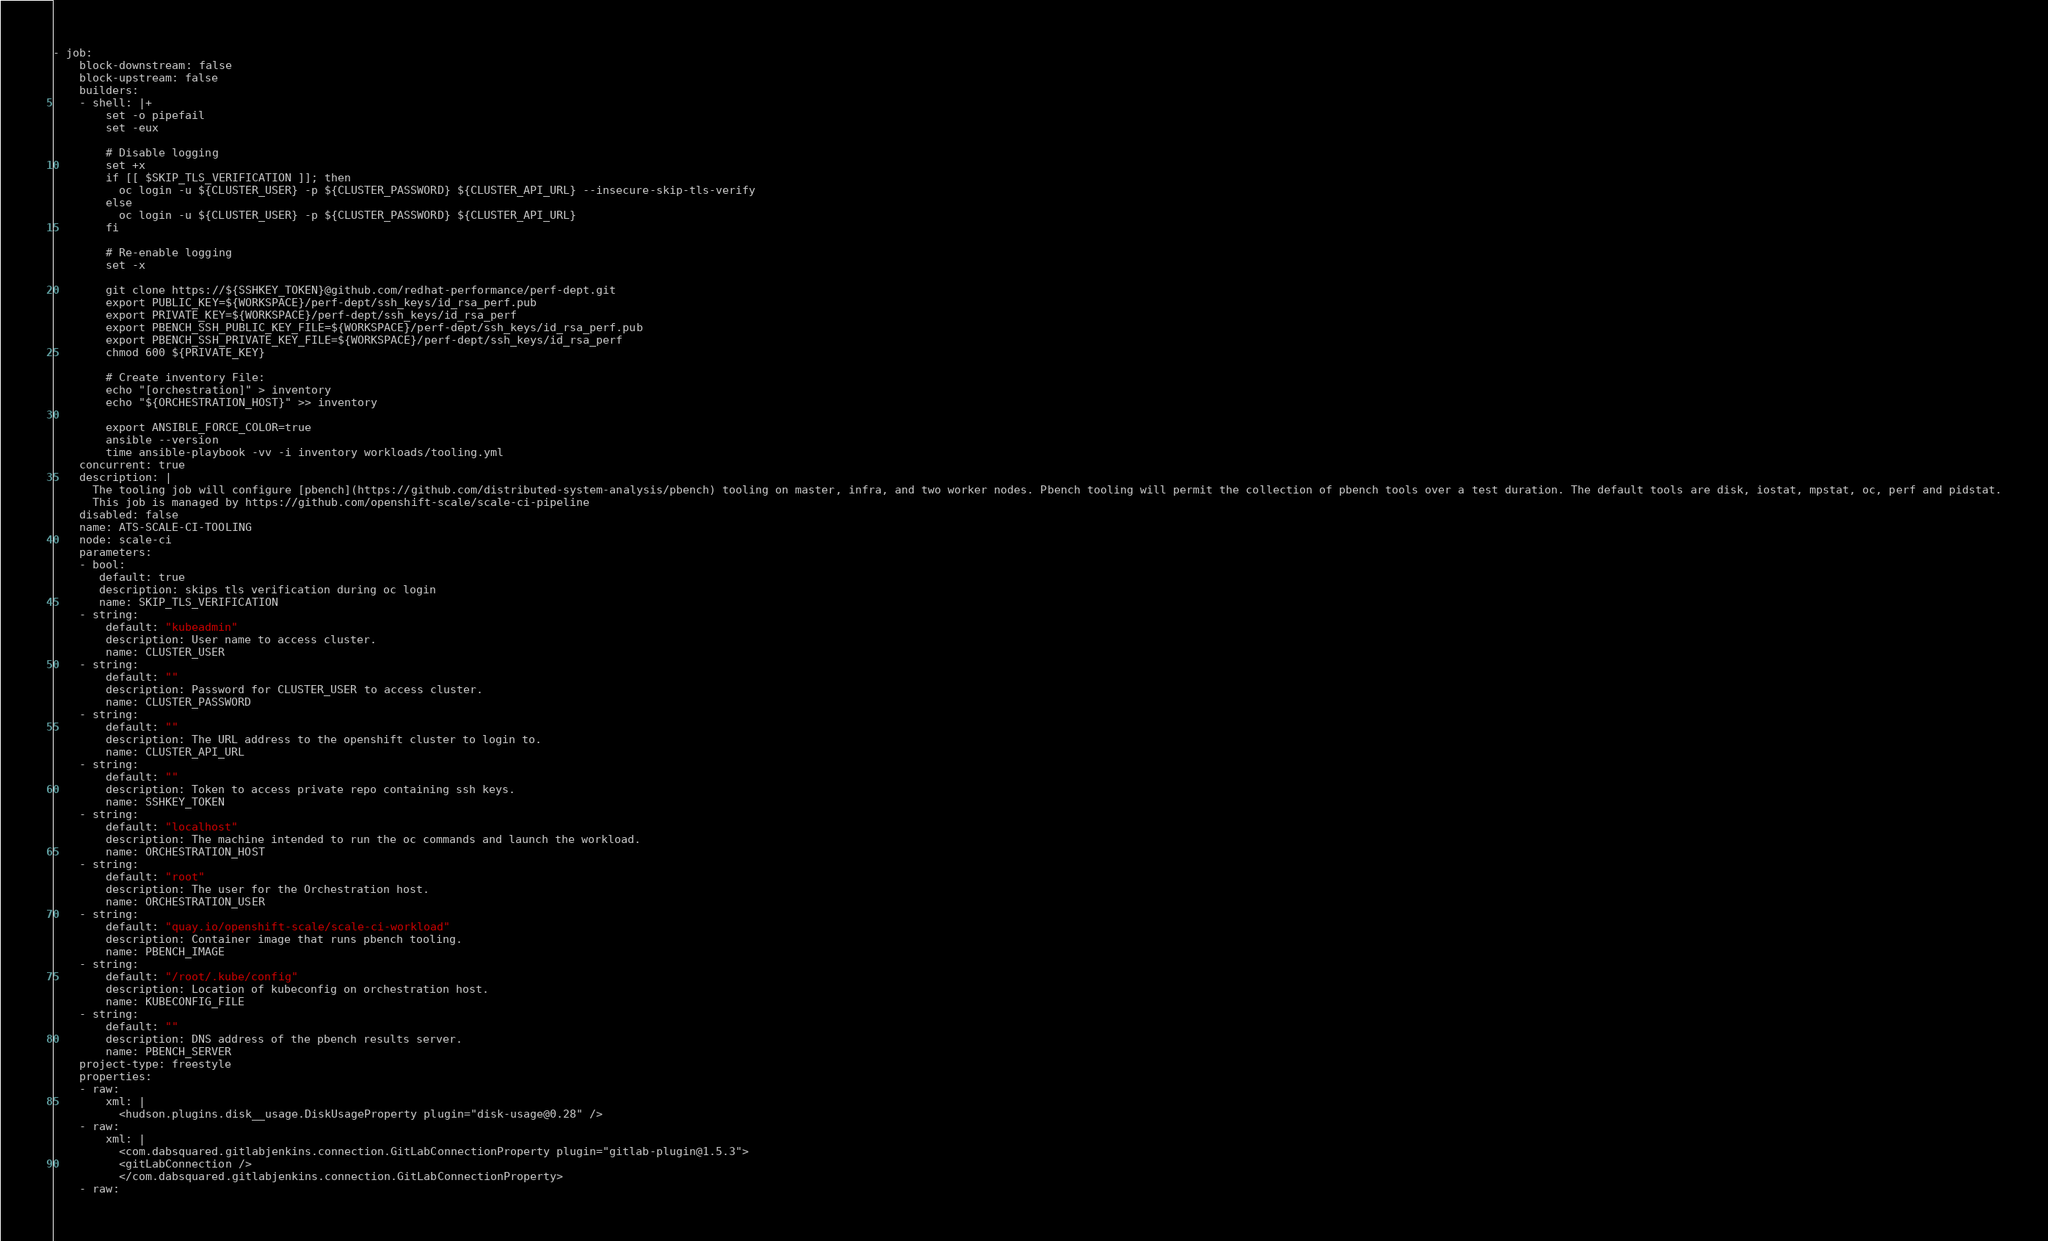Convert code to text. <code><loc_0><loc_0><loc_500><loc_500><_YAML_>- job:
    block-downstream: false
    block-upstream: false
    builders:
    - shell: |+
        set -o pipefail
        set -eux

        # Disable logging
        set +x
        if [[ $SKIP_TLS_VERIFICATION ]]; then
          oc login -u ${CLUSTER_USER} -p ${CLUSTER_PASSWORD} ${CLUSTER_API_URL} --insecure-skip-tls-verify
        else
          oc login -u ${CLUSTER_USER} -p ${CLUSTER_PASSWORD} ${CLUSTER_API_URL}
        fi

        # Re-enable logging
        set -x

        git clone https://${SSHKEY_TOKEN}@github.com/redhat-performance/perf-dept.git
        export PUBLIC_KEY=${WORKSPACE}/perf-dept/ssh_keys/id_rsa_perf.pub
        export PRIVATE_KEY=${WORKSPACE}/perf-dept/ssh_keys/id_rsa_perf
        export PBENCH_SSH_PUBLIC_KEY_FILE=${WORKSPACE}/perf-dept/ssh_keys/id_rsa_perf.pub
        export PBENCH_SSH_PRIVATE_KEY_FILE=${WORKSPACE}/perf-dept/ssh_keys/id_rsa_perf
        chmod 600 ${PRIVATE_KEY}

        # Create inventory File:
        echo "[orchestration]" > inventory
        echo "${ORCHESTRATION_HOST}" >> inventory

        export ANSIBLE_FORCE_COLOR=true
        ansible --version
        time ansible-playbook -vv -i inventory workloads/tooling.yml
    concurrent: true
    description: |
      The tooling job will configure [pbench](https://github.com/distributed-system-analysis/pbench) tooling on master, infra, and two worker nodes. Pbench tooling will permit the collection of pbench tools over a test duration. The default tools are disk, iostat, mpstat, oc, perf and pidstat.
      This job is managed by https://github.com/openshift-scale/scale-ci-pipeline
    disabled: false
    name: ATS-SCALE-CI-TOOLING
    node: scale-ci
    parameters:
    - bool:
       default: true
       description: skips tls verification during oc login
       name: SKIP_TLS_VERIFICATION
    - string:
        default: "kubeadmin"
        description: User name to access cluster.
        name: CLUSTER_USER
    - string:
        default: ""
        description: Password for CLUSTER_USER to access cluster.
        name: CLUSTER_PASSWORD
    - string:
        default: ""
        description: The URL address to the openshift cluster to login to.
        name: CLUSTER_API_URL
    - string:
        default: ""
        description: Token to access private repo containing ssh keys.
        name: SSHKEY_TOKEN
    - string:
        default: "localhost"
        description: The machine intended to run the oc commands and launch the workload.
        name: ORCHESTRATION_HOST
    - string:
        default: "root"
        description: The user for the Orchestration host.
        name: ORCHESTRATION_USER
    - string:
        default: "quay.io/openshift-scale/scale-ci-workload"
        description: Container image that runs pbench tooling.
        name: PBENCH_IMAGE
    - string:
        default: "/root/.kube/config"
        description: Location of kubeconfig on orchestration host.
        name: KUBECONFIG_FILE
    - string:
        default: ""
        description: DNS address of the pbench results server.
        name: PBENCH_SERVER
    project-type: freestyle
    properties:
    - raw:
        xml: |
          <hudson.plugins.disk__usage.DiskUsageProperty plugin="disk-usage@0.28" />
    - raw:
        xml: |
          <com.dabsquared.gitlabjenkins.connection.GitLabConnectionProperty plugin="gitlab-plugin@1.5.3">
          <gitLabConnection />
          </com.dabsquared.gitlabjenkins.connection.GitLabConnectionProperty>
    - raw:</code> 